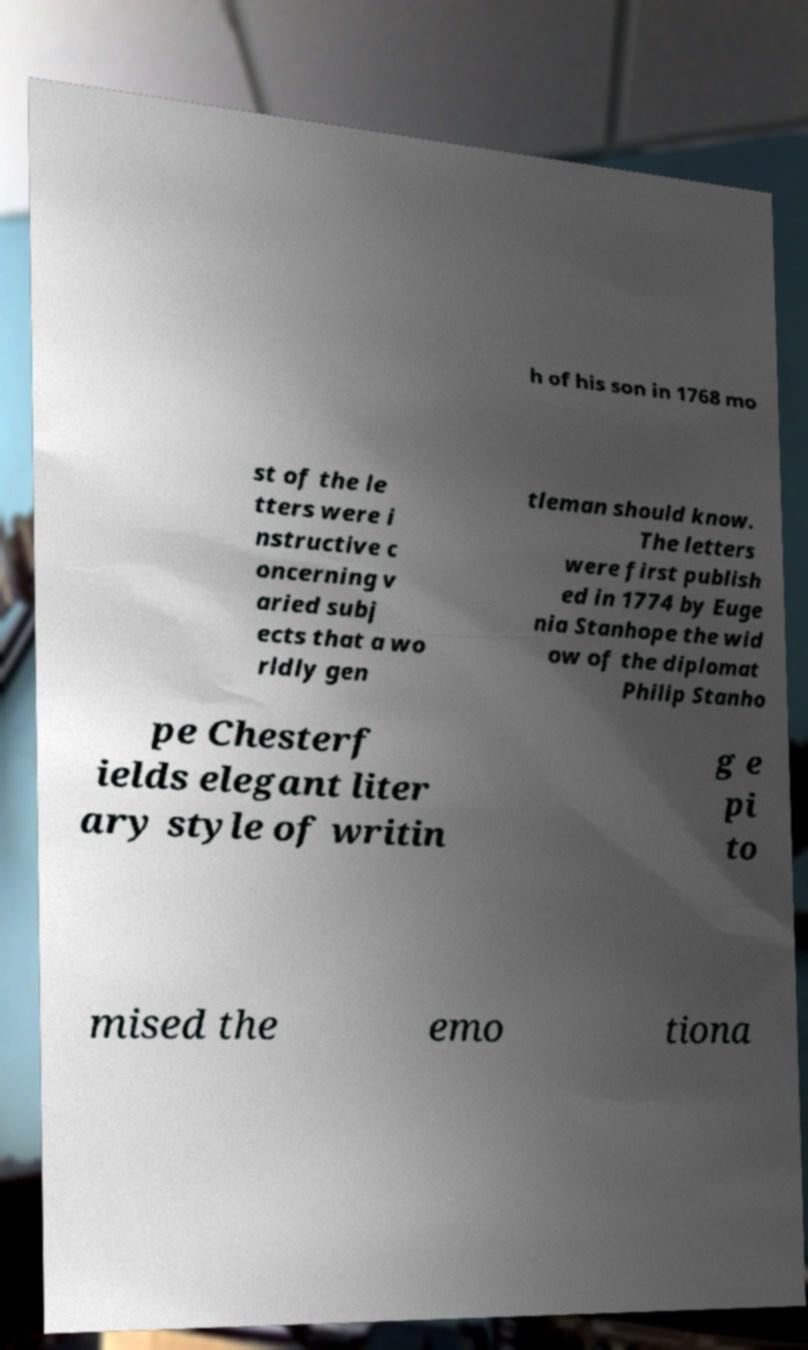What messages or text are displayed in this image? I need them in a readable, typed format. h of his son in 1768 mo st of the le tters were i nstructive c oncerning v aried subj ects that a wo rldly gen tleman should know. The letters were first publish ed in 1774 by Euge nia Stanhope the wid ow of the diplomat Philip Stanho pe Chesterf ields elegant liter ary style of writin g e pi to mised the emo tiona 